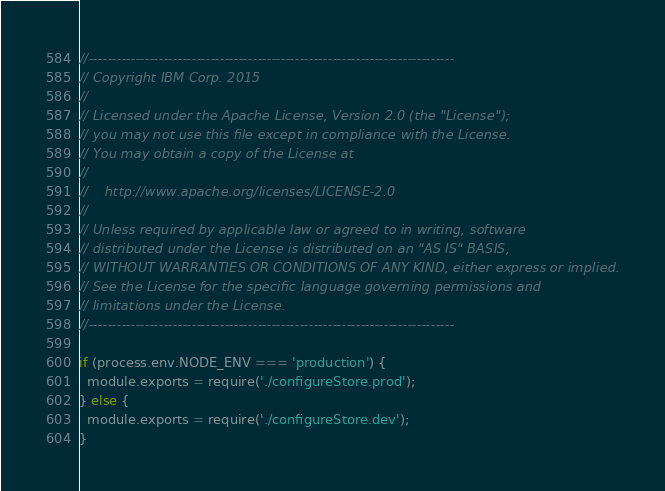Convert code to text. <code><loc_0><loc_0><loc_500><loc_500><_JavaScript_>//------------------------------------------------------------------------------
// Copyright IBM Corp. 2015
//
// Licensed under the Apache License, Version 2.0 (the "License");
// you may not use this file except in compliance with the License.
// You may obtain a copy of the License at
//
//    http://www.apache.org/licenses/LICENSE-2.0
//
// Unless required by applicable law or agreed to in writing, software
// distributed under the License is distributed on an "AS IS" BASIS,
// WITHOUT WARRANTIES OR CONDITIONS OF ANY KIND, either express or implied.
// See the License for the specific language governing permissions and
// limitations under the License.
//------------------------------------------------------------------------------

if (process.env.NODE_ENV === 'production') {
  module.exports = require('./configureStore.prod');
} else {
  module.exports = require('./configureStore.dev');
}
</code> 